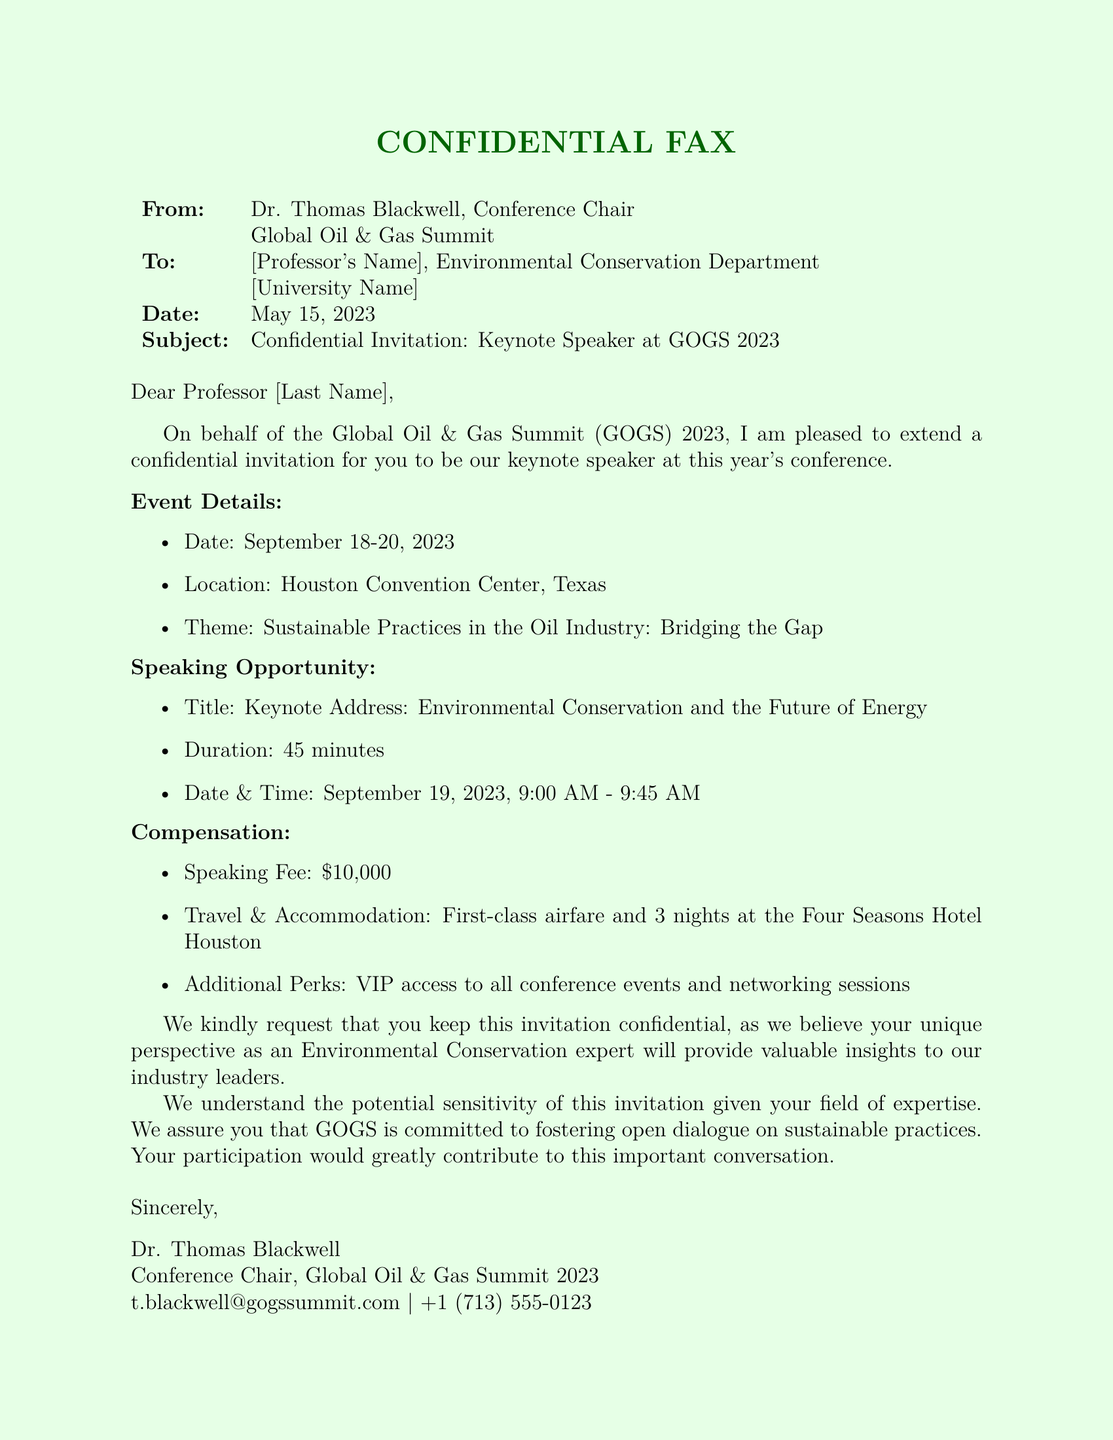What is the name of the conference? The name of the conference is mentioned in the document's subject line.
Answer: Global Oil & Gas Summit When is the conference scheduled to take place? The dates of the conference are specified under the Event Details section.
Answer: September 18-20, 2023 What is the speaking fee offered to the professor? The compensation section lists the fee amount.
Answer: $10,000 Who is the sender of the fax? The sender is identified at the beginning of the document.
Answer: Dr. Thomas Blackwell What is the main theme of the conference? The theme is provided in the Event Details section.
Answer: Sustainable Practices in the Oil Industry: Bridging the Gap What type of travel arrangement is included in the compensation? The document details travel accommodations under the Compensation section.
Answer: First-class airfare What is the location of the conference? The location is specified in the Event Details section of the document.
Answer: Houston Convention Center, Texas What additional perks are offered to the speaker? The perks are listed under the Compensation section of the fax.
Answer: VIP access to all conference events What is the duration of the keynote address? The duration is described in the Speaking Opportunity section.
Answer: 45 minutes 